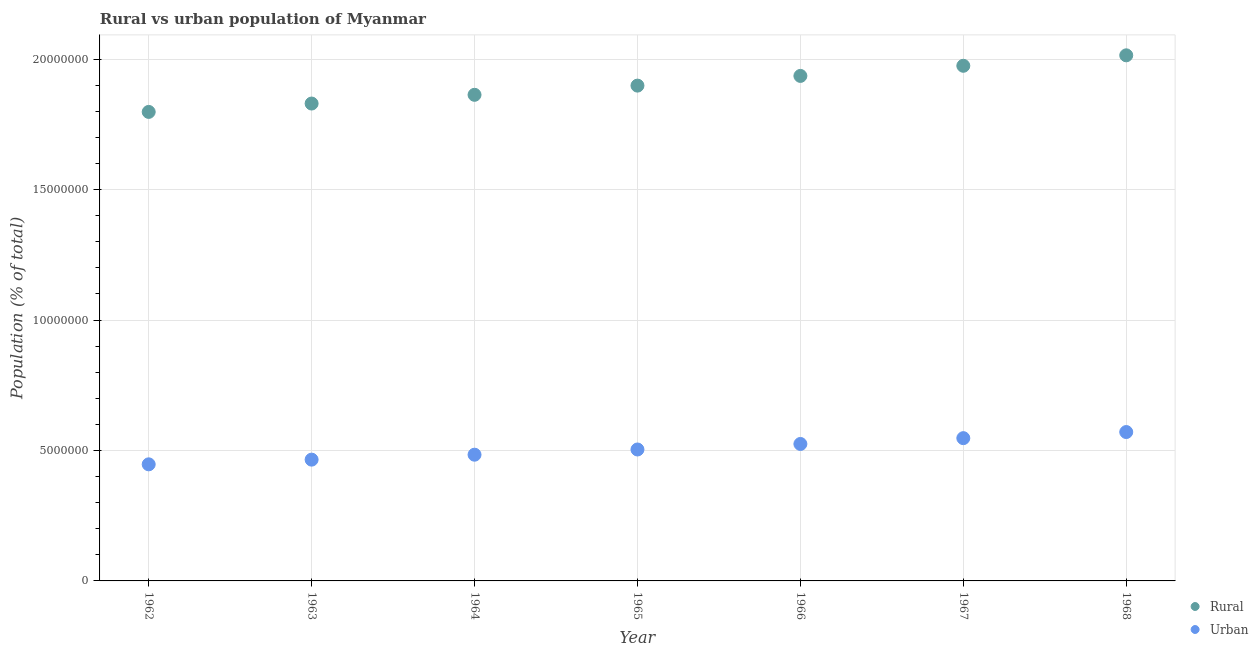What is the rural population density in 1965?
Your answer should be compact. 1.90e+07. Across all years, what is the maximum rural population density?
Your response must be concise. 2.01e+07. Across all years, what is the minimum rural population density?
Ensure brevity in your answer.  1.80e+07. In which year was the rural population density maximum?
Offer a terse response. 1968. What is the total rural population density in the graph?
Give a very brief answer. 1.33e+08. What is the difference between the urban population density in 1962 and that in 1964?
Ensure brevity in your answer.  -3.69e+05. What is the difference between the urban population density in 1966 and the rural population density in 1967?
Offer a terse response. -1.45e+07. What is the average urban population density per year?
Give a very brief answer. 5.06e+06. In the year 1962, what is the difference between the rural population density and urban population density?
Keep it short and to the point. 1.35e+07. What is the ratio of the rural population density in 1963 to that in 1966?
Give a very brief answer. 0.95. What is the difference between the highest and the second highest urban population density?
Offer a very short reply. 2.34e+05. What is the difference between the highest and the lowest rural population density?
Keep it short and to the point. 2.17e+06. Is the sum of the rural population density in 1966 and 1967 greater than the maximum urban population density across all years?
Provide a short and direct response. Yes. Does the rural population density monotonically increase over the years?
Ensure brevity in your answer.  Yes. Is the urban population density strictly less than the rural population density over the years?
Your answer should be compact. Yes. How many years are there in the graph?
Your answer should be compact. 7. Does the graph contain grids?
Give a very brief answer. Yes. What is the title of the graph?
Provide a succinct answer. Rural vs urban population of Myanmar. What is the label or title of the X-axis?
Provide a succinct answer. Year. What is the label or title of the Y-axis?
Your response must be concise. Population (% of total). What is the Population (% of total) of Rural in 1962?
Provide a succinct answer. 1.80e+07. What is the Population (% of total) in Urban in 1962?
Ensure brevity in your answer.  4.47e+06. What is the Population (% of total) of Rural in 1963?
Provide a short and direct response. 1.83e+07. What is the Population (% of total) in Urban in 1963?
Provide a succinct answer. 4.65e+06. What is the Population (% of total) in Rural in 1964?
Ensure brevity in your answer.  1.86e+07. What is the Population (% of total) in Urban in 1964?
Ensure brevity in your answer.  4.84e+06. What is the Population (% of total) of Rural in 1965?
Keep it short and to the point. 1.90e+07. What is the Population (% of total) of Urban in 1965?
Keep it short and to the point. 5.04e+06. What is the Population (% of total) of Rural in 1966?
Your answer should be compact. 1.94e+07. What is the Population (% of total) in Urban in 1966?
Offer a terse response. 5.25e+06. What is the Population (% of total) of Rural in 1967?
Your response must be concise. 1.97e+07. What is the Population (% of total) in Urban in 1967?
Provide a succinct answer. 5.47e+06. What is the Population (% of total) in Rural in 1968?
Your answer should be compact. 2.01e+07. What is the Population (% of total) in Urban in 1968?
Offer a very short reply. 5.71e+06. Across all years, what is the maximum Population (% of total) of Rural?
Make the answer very short. 2.01e+07. Across all years, what is the maximum Population (% of total) in Urban?
Your answer should be very brief. 5.71e+06. Across all years, what is the minimum Population (% of total) in Rural?
Your answer should be very brief. 1.80e+07. Across all years, what is the minimum Population (% of total) in Urban?
Give a very brief answer. 4.47e+06. What is the total Population (% of total) in Rural in the graph?
Your response must be concise. 1.33e+08. What is the total Population (% of total) in Urban in the graph?
Your answer should be compact. 3.54e+07. What is the difference between the Population (% of total) in Rural in 1962 and that in 1963?
Offer a terse response. -3.21e+05. What is the difference between the Population (% of total) of Urban in 1962 and that in 1963?
Provide a short and direct response. -1.80e+05. What is the difference between the Population (% of total) in Rural in 1962 and that in 1964?
Your response must be concise. -6.55e+05. What is the difference between the Population (% of total) of Urban in 1962 and that in 1964?
Keep it short and to the point. -3.69e+05. What is the difference between the Population (% of total) in Rural in 1962 and that in 1965?
Provide a short and direct response. -1.01e+06. What is the difference between the Population (% of total) in Urban in 1962 and that in 1965?
Give a very brief answer. -5.69e+05. What is the difference between the Population (% of total) in Rural in 1962 and that in 1966?
Your answer should be compact. -1.38e+06. What is the difference between the Population (% of total) in Urban in 1962 and that in 1966?
Your answer should be very brief. -7.80e+05. What is the difference between the Population (% of total) of Rural in 1962 and that in 1967?
Your answer should be very brief. -1.77e+06. What is the difference between the Population (% of total) of Urban in 1962 and that in 1967?
Your answer should be compact. -1.00e+06. What is the difference between the Population (% of total) in Rural in 1962 and that in 1968?
Provide a succinct answer. -2.17e+06. What is the difference between the Population (% of total) in Urban in 1962 and that in 1968?
Give a very brief answer. -1.24e+06. What is the difference between the Population (% of total) of Rural in 1963 and that in 1964?
Your response must be concise. -3.35e+05. What is the difference between the Population (% of total) in Urban in 1963 and that in 1964?
Make the answer very short. -1.89e+05. What is the difference between the Population (% of total) in Rural in 1963 and that in 1965?
Provide a succinct answer. -6.87e+05. What is the difference between the Population (% of total) of Urban in 1963 and that in 1965?
Your response must be concise. -3.89e+05. What is the difference between the Population (% of total) in Rural in 1963 and that in 1966?
Make the answer very short. -1.06e+06. What is the difference between the Population (% of total) in Urban in 1963 and that in 1966?
Give a very brief answer. -6.01e+05. What is the difference between the Population (% of total) of Rural in 1963 and that in 1967?
Ensure brevity in your answer.  -1.45e+06. What is the difference between the Population (% of total) of Urban in 1963 and that in 1967?
Provide a succinct answer. -8.24e+05. What is the difference between the Population (% of total) of Rural in 1963 and that in 1968?
Offer a very short reply. -1.85e+06. What is the difference between the Population (% of total) in Urban in 1963 and that in 1968?
Make the answer very short. -1.06e+06. What is the difference between the Population (% of total) of Rural in 1964 and that in 1965?
Provide a short and direct response. -3.53e+05. What is the difference between the Population (% of total) of Urban in 1964 and that in 1965?
Offer a very short reply. -2.00e+05. What is the difference between the Population (% of total) in Rural in 1964 and that in 1966?
Ensure brevity in your answer.  -7.24e+05. What is the difference between the Population (% of total) of Urban in 1964 and that in 1966?
Provide a short and direct response. -4.12e+05. What is the difference between the Population (% of total) of Rural in 1964 and that in 1967?
Give a very brief answer. -1.11e+06. What is the difference between the Population (% of total) in Urban in 1964 and that in 1967?
Your answer should be compact. -6.35e+05. What is the difference between the Population (% of total) of Rural in 1964 and that in 1968?
Keep it short and to the point. -1.51e+06. What is the difference between the Population (% of total) of Urban in 1964 and that in 1968?
Provide a succinct answer. -8.68e+05. What is the difference between the Population (% of total) of Rural in 1965 and that in 1966?
Make the answer very short. -3.72e+05. What is the difference between the Population (% of total) of Urban in 1965 and that in 1966?
Provide a short and direct response. -2.12e+05. What is the difference between the Population (% of total) in Rural in 1965 and that in 1967?
Ensure brevity in your answer.  -7.60e+05. What is the difference between the Population (% of total) of Urban in 1965 and that in 1967?
Offer a terse response. -4.35e+05. What is the difference between the Population (% of total) of Rural in 1965 and that in 1968?
Offer a terse response. -1.16e+06. What is the difference between the Population (% of total) of Urban in 1965 and that in 1968?
Your answer should be very brief. -6.69e+05. What is the difference between the Population (% of total) of Rural in 1966 and that in 1967?
Offer a very short reply. -3.88e+05. What is the difference between the Population (% of total) of Urban in 1966 and that in 1967?
Provide a succinct answer. -2.23e+05. What is the difference between the Population (% of total) of Rural in 1966 and that in 1968?
Offer a very short reply. -7.89e+05. What is the difference between the Population (% of total) in Urban in 1966 and that in 1968?
Ensure brevity in your answer.  -4.57e+05. What is the difference between the Population (% of total) in Rural in 1967 and that in 1968?
Offer a terse response. -4.01e+05. What is the difference between the Population (% of total) in Urban in 1967 and that in 1968?
Keep it short and to the point. -2.34e+05. What is the difference between the Population (% of total) in Rural in 1962 and the Population (% of total) in Urban in 1963?
Ensure brevity in your answer.  1.33e+07. What is the difference between the Population (% of total) of Rural in 1962 and the Population (% of total) of Urban in 1964?
Keep it short and to the point. 1.31e+07. What is the difference between the Population (% of total) of Rural in 1962 and the Population (% of total) of Urban in 1965?
Provide a short and direct response. 1.29e+07. What is the difference between the Population (% of total) of Rural in 1962 and the Population (% of total) of Urban in 1966?
Provide a succinct answer. 1.27e+07. What is the difference between the Population (% of total) in Rural in 1962 and the Population (% of total) in Urban in 1967?
Provide a succinct answer. 1.25e+07. What is the difference between the Population (% of total) of Rural in 1962 and the Population (% of total) of Urban in 1968?
Provide a succinct answer. 1.23e+07. What is the difference between the Population (% of total) of Rural in 1963 and the Population (% of total) of Urban in 1964?
Make the answer very short. 1.35e+07. What is the difference between the Population (% of total) in Rural in 1963 and the Population (% of total) in Urban in 1965?
Offer a terse response. 1.33e+07. What is the difference between the Population (% of total) in Rural in 1963 and the Population (% of total) in Urban in 1966?
Offer a very short reply. 1.30e+07. What is the difference between the Population (% of total) in Rural in 1963 and the Population (% of total) in Urban in 1967?
Give a very brief answer. 1.28e+07. What is the difference between the Population (% of total) of Rural in 1963 and the Population (% of total) of Urban in 1968?
Provide a short and direct response. 1.26e+07. What is the difference between the Population (% of total) in Rural in 1964 and the Population (% of total) in Urban in 1965?
Offer a terse response. 1.36e+07. What is the difference between the Population (% of total) in Rural in 1964 and the Population (% of total) in Urban in 1966?
Your answer should be very brief. 1.34e+07. What is the difference between the Population (% of total) in Rural in 1964 and the Population (% of total) in Urban in 1967?
Offer a very short reply. 1.32e+07. What is the difference between the Population (% of total) in Rural in 1964 and the Population (% of total) in Urban in 1968?
Make the answer very short. 1.29e+07. What is the difference between the Population (% of total) of Rural in 1965 and the Population (% of total) of Urban in 1966?
Make the answer very short. 1.37e+07. What is the difference between the Population (% of total) of Rural in 1965 and the Population (% of total) of Urban in 1967?
Provide a succinct answer. 1.35e+07. What is the difference between the Population (% of total) in Rural in 1965 and the Population (% of total) in Urban in 1968?
Your answer should be very brief. 1.33e+07. What is the difference between the Population (% of total) in Rural in 1966 and the Population (% of total) in Urban in 1967?
Ensure brevity in your answer.  1.39e+07. What is the difference between the Population (% of total) in Rural in 1966 and the Population (% of total) in Urban in 1968?
Offer a terse response. 1.37e+07. What is the difference between the Population (% of total) of Rural in 1967 and the Population (% of total) of Urban in 1968?
Your answer should be very brief. 1.40e+07. What is the average Population (% of total) in Rural per year?
Make the answer very short. 1.90e+07. What is the average Population (% of total) in Urban per year?
Give a very brief answer. 5.06e+06. In the year 1962, what is the difference between the Population (% of total) in Rural and Population (% of total) in Urban?
Ensure brevity in your answer.  1.35e+07. In the year 1963, what is the difference between the Population (% of total) of Rural and Population (% of total) of Urban?
Your response must be concise. 1.36e+07. In the year 1964, what is the difference between the Population (% of total) of Rural and Population (% of total) of Urban?
Your answer should be compact. 1.38e+07. In the year 1965, what is the difference between the Population (% of total) of Rural and Population (% of total) of Urban?
Provide a short and direct response. 1.39e+07. In the year 1966, what is the difference between the Population (% of total) in Rural and Population (% of total) in Urban?
Your answer should be very brief. 1.41e+07. In the year 1967, what is the difference between the Population (% of total) in Rural and Population (% of total) in Urban?
Provide a short and direct response. 1.43e+07. In the year 1968, what is the difference between the Population (% of total) in Rural and Population (% of total) in Urban?
Your response must be concise. 1.44e+07. What is the ratio of the Population (% of total) of Rural in 1962 to that in 1963?
Your response must be concise. 0.98. What is the ratio of the Population (% of total) of Urban in 1962 to that in 1963?
Your answer should be very brief. 0.96. What is the ratio of the Population (% of total) of Rural in 1962 to that in 1964?
Provide a succinct answer. 0.96. What is the ratio of the Population (% of total) in Urban in 1962 to that in 1964?
Your answer should be very brief. 0.92. What is the ratio of the Population (% of total) in Rural in 1962 to that in 1965?
Your response must be concise. 0.95. What is the ratio of the Population (% of total) in Urban in 1962 to that in 1965?
Ensure brevity in your answer.  0.89. What is the ratio of the Population (% of total) of Rural in 1962 to that in 1966?
Offer a terse response. 0.93. What is the ratio of the Population (% of total) of Urban in 1962 to that in 1966?
Give a very brief answer. 0.85. What is the ratio of the Population (% of total) of Rural in 1962 to that in 1967?
Offer a very short reply. 0.91. What is the ratio of the Population (% of total) of Urban in 1962 to that in 1967?
Offer a terse response. 0.82. What is the ratio of the Population (% of total) in Rural in 1962 to that in 1968?
Offer a very short reply. 0.89. What is the ratio of the Population (% of total) of Urban in 1962 to that in 1968?
Make the answer very short. 0.78. What is the ratio of the Population (% of total) of Urban in 1963 to that in 1964?
Provide a succinct answer. 0.96. What is the ratio of the Population (% of total) in Rural in 1963 to that in 1965?
Give a very brief answer. 0.96. What is the ratio of the Population (% of total) of Urban in 1963 to that in 1965?
Keep it short and to the point. 0.92. What is the ratio of the Population (% of total) of Rural in 1963 to that in 1966?
Give a very brief answer. 0.95. What is the ratio of the Population (% of total) in Urban in 1963 to that in 1966?
Provide a succinct answer. 0.89. What is the ratio of the Population (% of total) of Rural in 1963 to that in 1967?
Offer a very short reply. 0.93. What is the ratio of the Population (% of total) of Urban in 1963 to that in 1967?
Make the answer very short. 0.85. What is the ratio of the Population (% of total) in Rural in 1963 to that in 1968?
Make the answer very short. 0.91. What is the ratio of the Population (% of total) of Urban in 1963 to that in 1968?
Your response must be concise. 0.81. What is the ratio of the Population (% of total) in Rural in 1964 to that in 1965?
Provide a short and direct response. 0.98. What is the ratio of the Population (% of total) in Urban in 1964 to that in 1965?
Your answer should be very brief. 0.96. What is the ratio of the Population (% of total) of Rural in 1964 to that in 1966?
Make the answer very short. 0.96. What is the ratio of the Population (% of total) in Urban in 1964 to that in 1966?
Your answer should be very brief. 0.92. What is the ratio of the Population (% of total) in Rural in 1964 to that in 1967?
Offer a terse response. 0.94. What is the ratio of the Population (% of total) of Urban in 1964 to that in 1967?
Give a very brief answer. 0.88. What is the ratio of the Population (% of total) in Rural in 1964 to that in 1968?
Offer a terse response. 0.92. What is the ratio of the Population (% of total) in Urban in 1964 to that in 1968?
Your response must be concise. 0.85. What is the ratio of the Population (% of total) of Rural in 1965 to that in 1966?
Ensure brevity in your answer.  0.98. What is the ratio of the Population (% of total) of Urban in 1965 to that in 1966?
Keep it short and to the point. 0.96. What is the ratio of the Population (% of total) of Rural in 1965 to that in 1967?
Keep it short and to the point. 0.96. What is the ratio of the Population (% of total) of Urban in 1965 to that in 1967?
Your answer should be compact. 0.92. What is the ratio of the Population (% of total) of Rural in 1965 to that in 1968?
Offer a very short reply. 0.94. What is the ratio of the Population (% of total) of Urban in 1965 to that in 1968?
Your answer should be very brief. 0.88. What is the ratio of the Population (% of total) in Rural in 1966 to that in 1967?
Make the answer very short. 0.98. What is the ratio of the Population (% of total) in Urban in 1966 to that in 1967?
Your response must be concise. 0.96. What is the ratio of the Population (% of total) of Rural in 1966 to that in 1968?
Ensure brevity in your answer.  0.96. What is the ratio of the Population (% of total) in Urban in 1966 to that in 1968?
Provide a succinct answer. 0.92. What is the ratio of the Population (% of total) in Rural in 1967 to that in 1968?
Give a very brief answer. 0.98. What is the ratio of the Population (% of total) of Urban in 1967 to that in 1968?
Your answer should be compact. 0.96. What is the difference between the highest and the second highest Population (% of total) in Rural?
Offer a terse response. 4.01e+05. What is the difference between the highest and the second highest Population (% of total) of Urban?
Provide a short and direct response. 2.34e+05. What is the difference between the highest and the lowest Population (% of total) in Rural?
Offer a terse response. 2.17e+06. What is the difference between the highest and the lowest Population (% of total) of Urban?
Make the answer very short. 1.24e+06. 